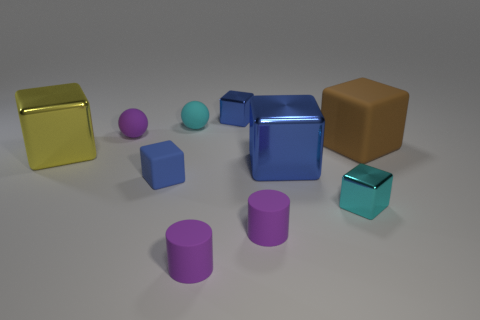Subtract all brown cylinders. How many blue cubes are left? 3 Subtract all cyan metallic cubes. How many cubes are left? 5 Subtract 2 cubes. How many cubes are left? 4 Subtract all brown blocks. How many blocks are left? 5 Subtract all brown cubes. Subtract all yellow balls. How many cubes are left? 5 Subtract all cubes. How many objects are left? 4 Add 10 big purple matte objects. How many big purple matte objects exist? 10 Subtract 0 green cylinders. How many objects are left? 10 Subtract all big cyan matte spheres. Subtract all large yellow metal objects. How many objects are left? 9 Add 4 cyan blocks. How many cyan blocks are left? 5 